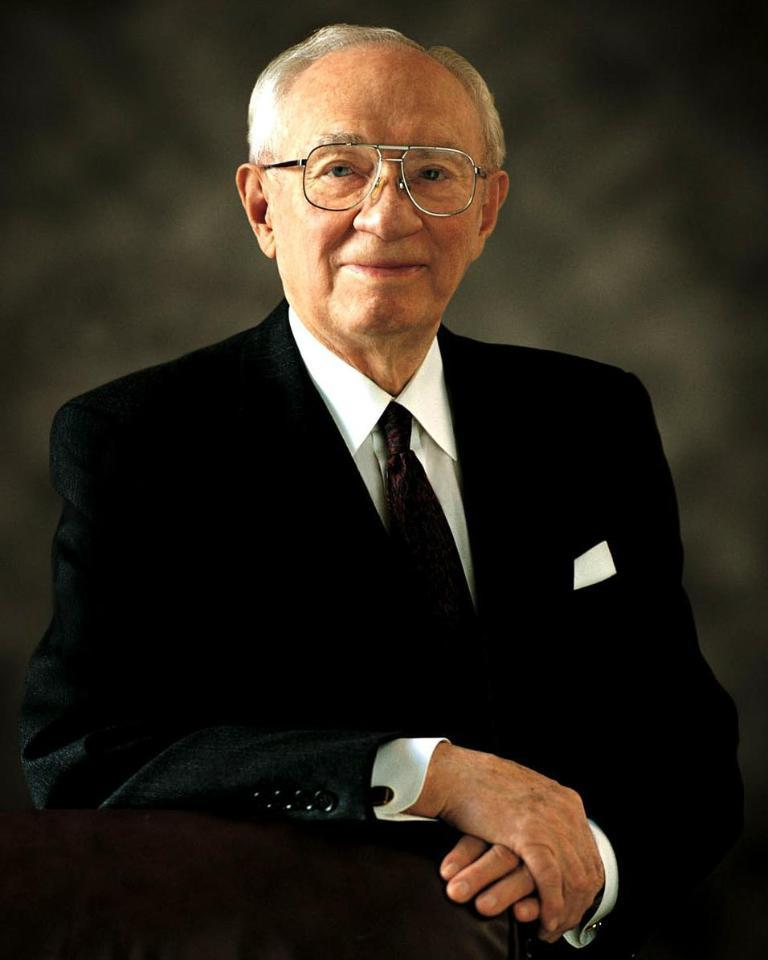What is the main subject of the image? The main subject of the image is a picture of an old man. What is the old man wearing in the image? The old man is wearing a black suit and a black tie in the image. What invention is the old man holding in the image? There is no invention present in the image; it only features a picture of an old man wearing a black suit and a black tie. What star is the old man looking at in the image? There is no object or celestial body present in the image; it only features a picture of an old man wearing a black suit and a black tie. 